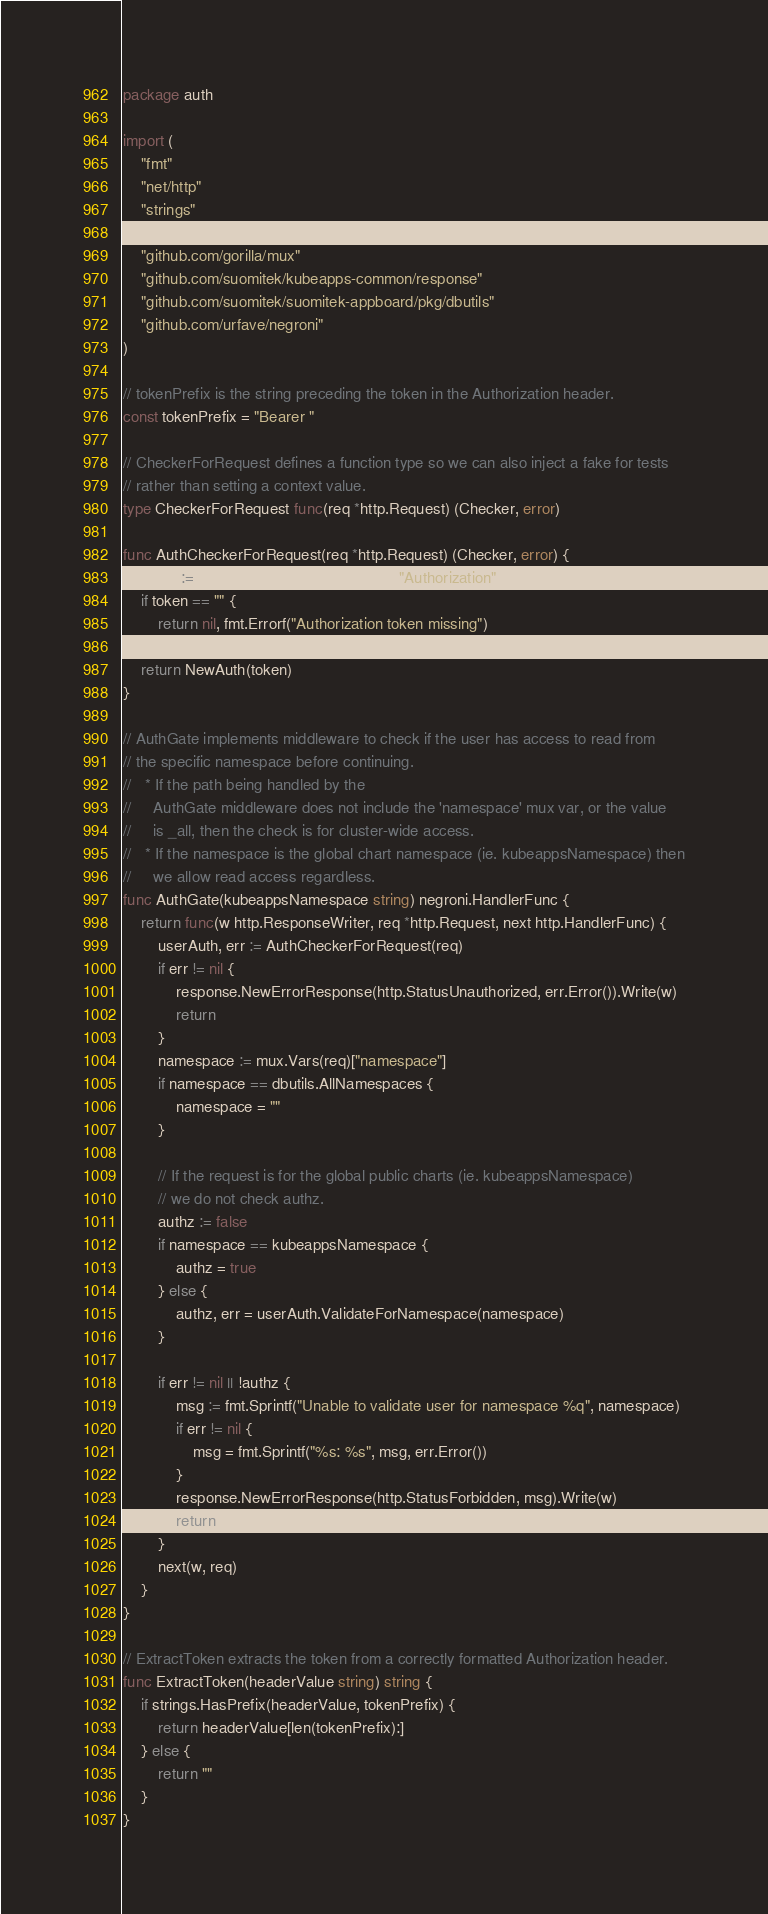Convert code to text. <code><loc_0><loc_0><loc_500><loc_500><_Go_>package auth

import (
	"fmt"
	"net/http"
	"strings"

	"github.com/gorilla/mux"
	"github.com/suomitek/kubeapps-common/response"
	"github.com/suomitek/suomitek-appboard/pkg/dbutils"
	"github.com/urfave/negroni"
)

// tokenPrefix is the string preceding the token in the Authorization header.
const tokenPrefix = "Bearer "

// CheckerForRequest defines a function type so we can also inject a fake for tests
// rather than setting a context value.
type CheckerForRequest func(req *http.Request) (Checker, error)

func AuthCheckerForRequest(req *http.Request) (Checker, error) {
	token := ExtractToken(req.Header.Get("Authorization"))
	if token == "" {
		return nil, fmt.Errorf("Authorization token missing")
	}
	return NewAuth(token)
}

// AuthGate implements middleware to check if the user has access to read from
// the specific namespace before continuing.
//   * If the path being handled by the
//     AuthGate middleware does not include the 'namespace' mux var, or the value
//     is _all, then the check is for cluster-wide access.
//   * If the namespace is the global chart namespace (ie. kubeappsNamespace) then
//     we allow read access regardless.
func AuthGate(kubeappsNamespace string) negroni.HandlerFunc {
	return func(w http.ResponseWriter, req *http.Request, next http.HandlerFunc) {
		userAuth, err := AuthCheckerForRequest(req)
		if err != nil {
			response.NewErrorResponse(http.StatusUnauthorized, err.Error()).Write(w)
			return
		}
		namespace := mux.Vars(req)["namespace"]
		if namespace == dbutils.AllNamespaces {
			namespace = ""
		}

		// If the request is for the global public charts (ie. kubeappsNamespace)
		// we do not check authz.
		authz := false
		if namespace == kubeappsNamespace {
			authz = true
		} else {
			authz, err = userAuth.ValidateForNamespace(namespace)
		}

		if err != nil || !authz {
			msg := fmt.Sprintf("Unable to validate user for namespace %q", namespace)
			if err != nil {
				msg = fmt.Sprintf("%s: %s", msg, err.Error())
			}
			response.NewErrorResponse(http.StatusForbidden, msg).Write(w)
			return
		}
		next(w, req)
	}
}

// ExtractToken extracts the token from a correctly formatted Authorization header.
func ExtractToken(headerValue string) string {
	if strings.HasPrefix(headerValue, tokenPrefix) {
		return headerValue[len(tokenPrefix):]
	} else {
		return ""
	}
}
</code> 